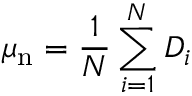<formula> <loc_0><loc_0><loc_500><loc_500>\mu _ { n } = \frac { 1 } { N } \sum _ { i = 1 } ^ { N } D _ { i }</formula> 